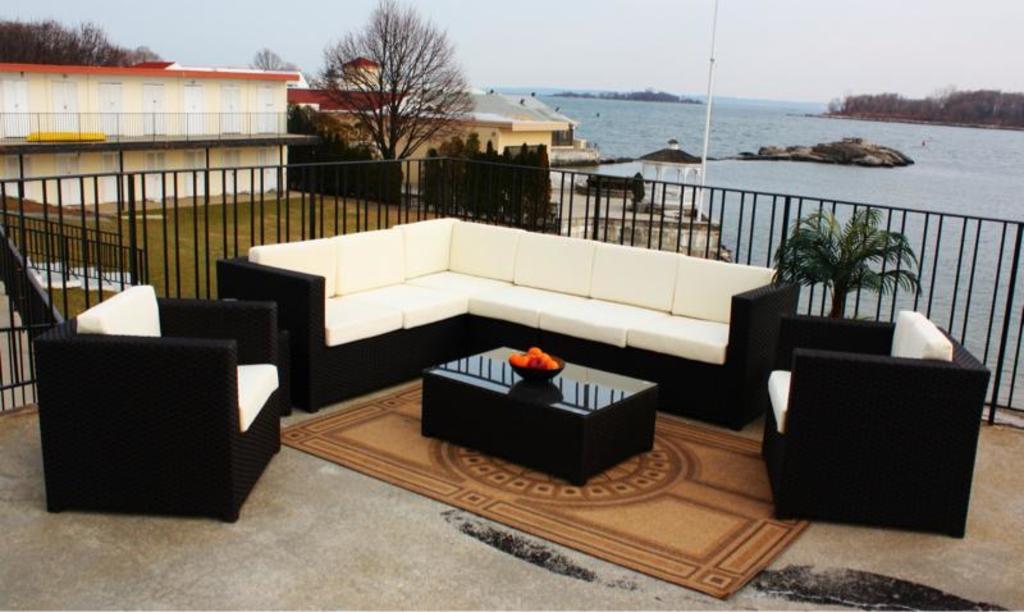How would you summarize this image in a sentence or two? There is a black and white sofa. Near to it there are two chairs. In front of it there is a table. On the table there is a bowl with some fruits. There is a carpet. Behind it there is a railings. In the background there are water , trees, buildings and sky. 